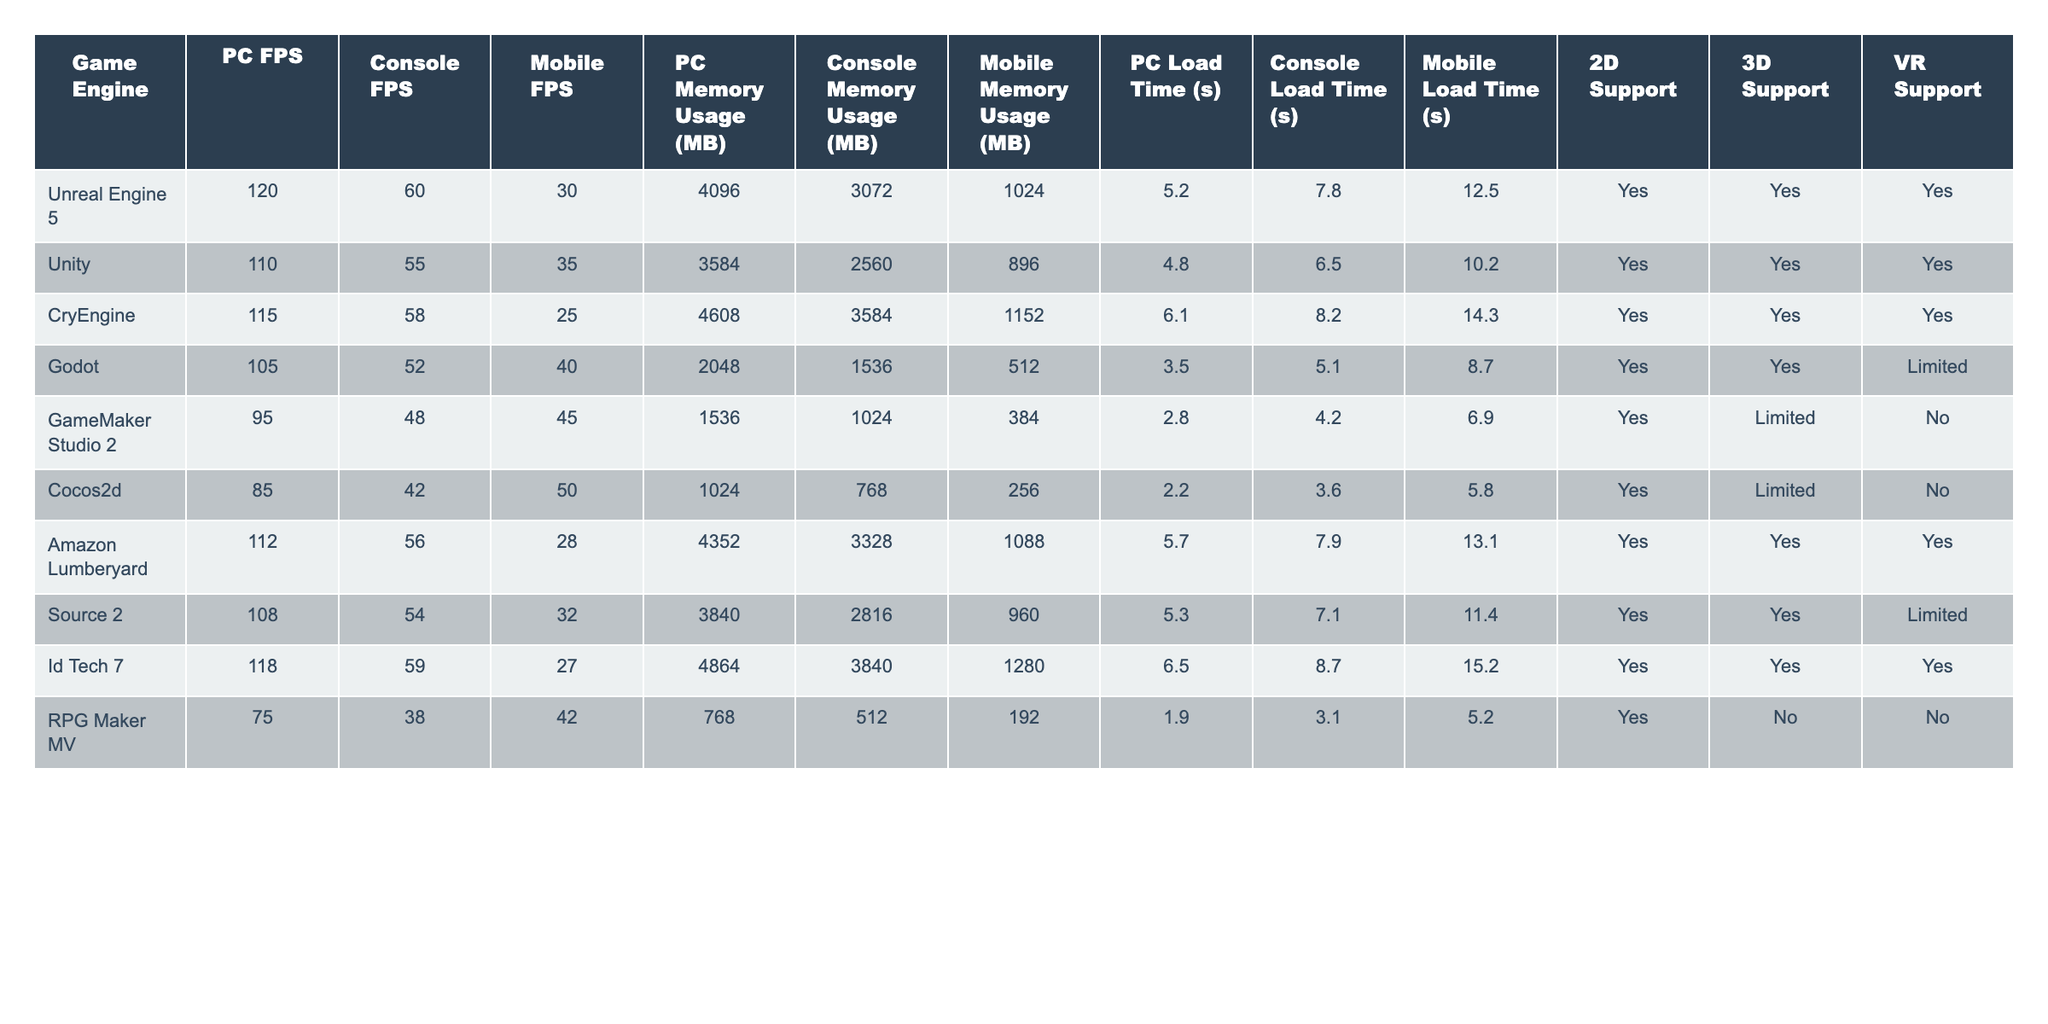What is the maximum FPS achieved on console by any game engine? Looking at the "Console FPS" column, the highest value is 60 FPS achieved by Unreal Engine 5.
Answer: 60 FPS Which game engine has the lowest memory usage on mobile? In the "Mobile Memory Usage (MB)" column, the lowest value is 256 MB for Cocos2d.
Answer: 256 MB What is the average PC Load Time across all game engines? The PC Load Time values are: 5.2, 4.8, 6.1, 3.5, 2.8, 2.2, 5.7, 5.3, 6.5, and 1.9. Summing these gives 42.0 seconds, and dividing by 10 (the number of engines) gives an average of 4.2 seconds.
Answer: 4.2 seconds Which game engine has the highest 3D support while having the least PC memory usage? Looking at the 3D Support and PC Memory Usage columns, Godot has 3D support and the lowest PC Memory Usage of 2048 MB.
Answer: Godot Is there any game engine that supports VR but does not support 2D? Examining the "VR Support" and "2D Support" columns, RPG Maker MV supports VR but does not support 2D.
Answer: Yes What is the difference in FPS between Unreal Engine 5 and GameMaker Studio 2 on PC? Unreal Engine 5 has 120 FPS and GameMaker Studio 2 has 95 FPS on PC. The difference is 120 - 95 = 25 FPS.
Answer: 25 FPS How many game engines have a Load Time of less than 5 seconds on mobile? The Mobile Load Time values are: 12.5, 10.2, 14.3, 8.7, 6.9, 5.8, 13.1, 11.4, 15.2, and 5.2. Only GameMaker Studio 2, Cocos2d, and RPG Maker MV have Load Times less than 5 seconds—totaling 3 engines.
Answer: 3 engines Which engine has the greatest discrepancy between PC and Mobile FPS? The differences are as follows: Unreal Engine 5 (90), Unity (75), CryEngine (90), Godot (65), GameMaker Studio 2 (50), Cocos2d (35), Amazon Lumberyard (84), Source 2 (76), Id Tech 7 (91), RPG Maker MV (37). The greatest discrepancy is with Id Tech 7, with a difference of 91 FPS (118 - 27).
Answer: Id Tech 7 What percentage of engines have both 2D and 3D support? Out of the 10 engines listed, 7 have both 2D and 3D support (Unreal, Unity, CryEngine, Godot, Amazon, Source 2, Id Tech 7). To find the percentage: (7 / 10) * 100 = 70%.
Answer: 70% Which game engine has the longest load time for consoles? The "Console Load Time (s)" column shows the longest time is 8.7 seconds for Id Tech 7.
Answer: 8.7 seconds 